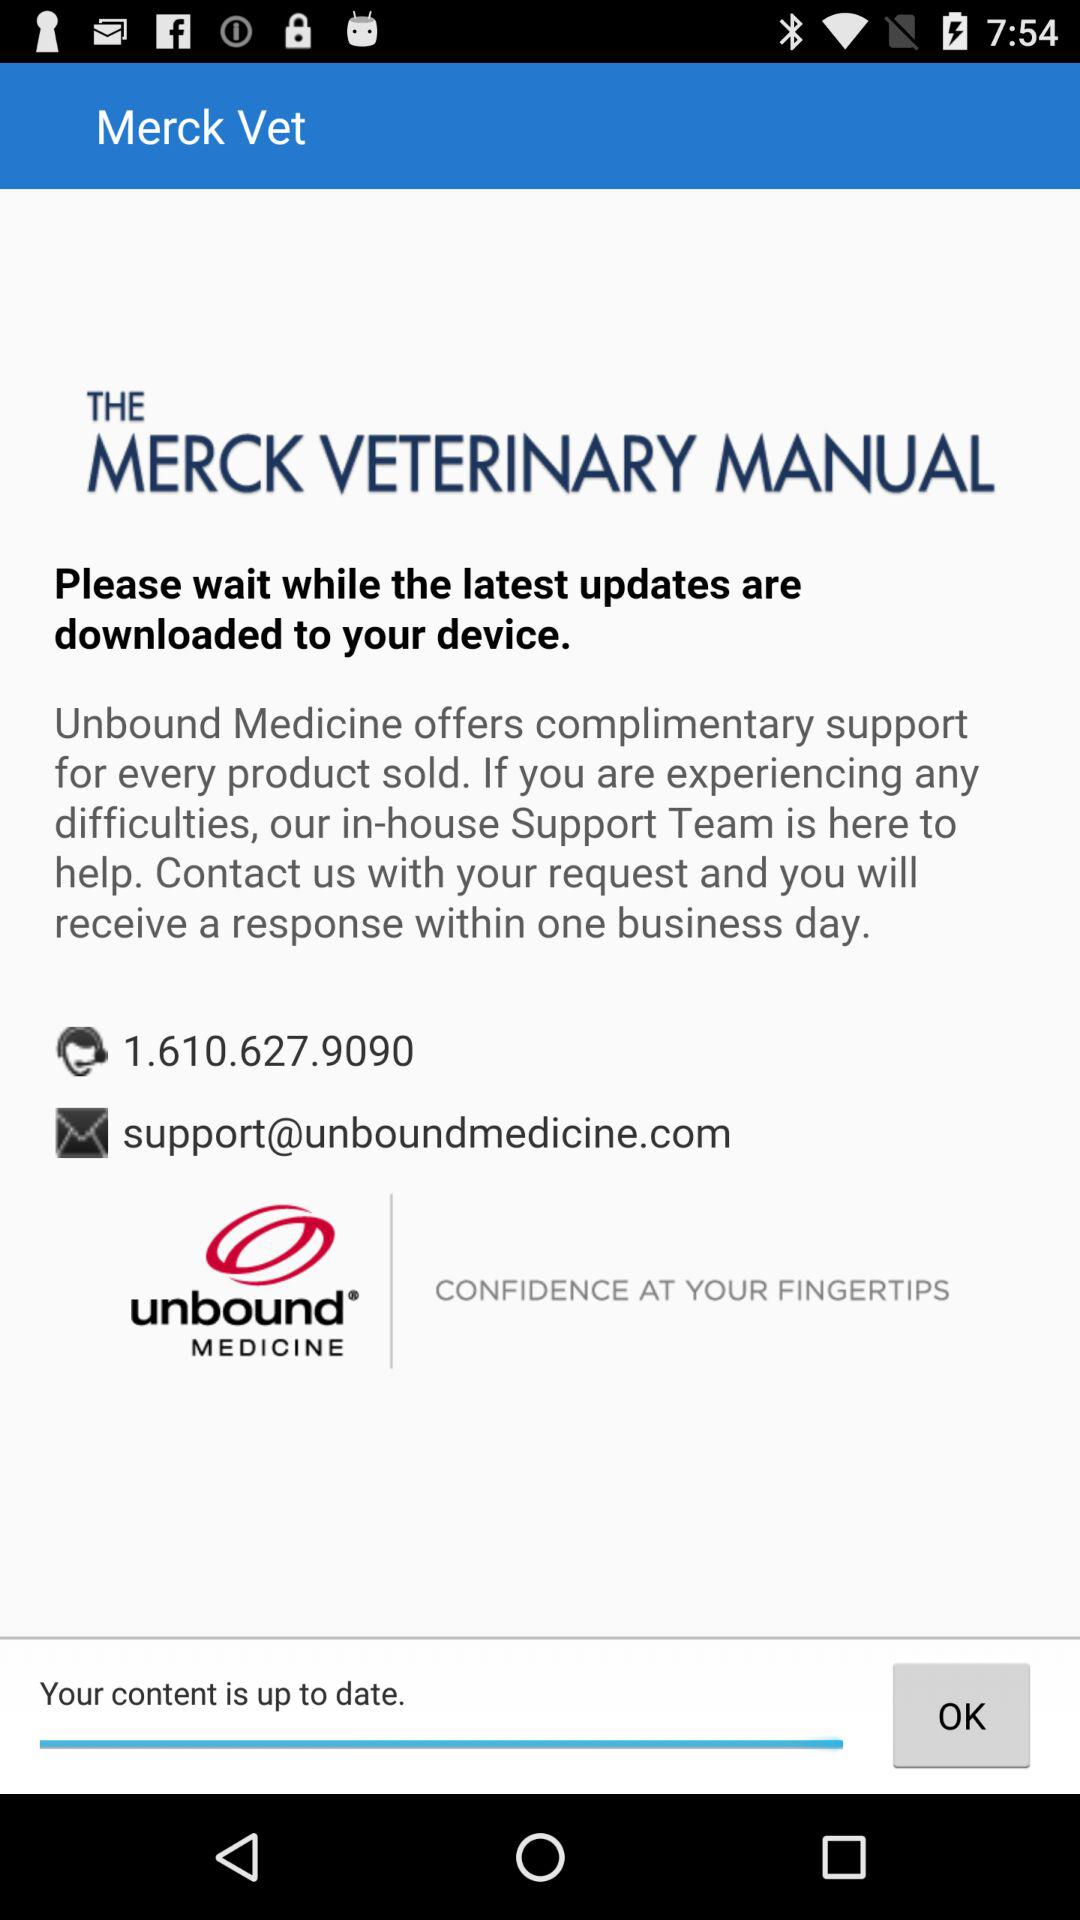How many support contact options are there?
Answer the question using a single word or phrase. 2 